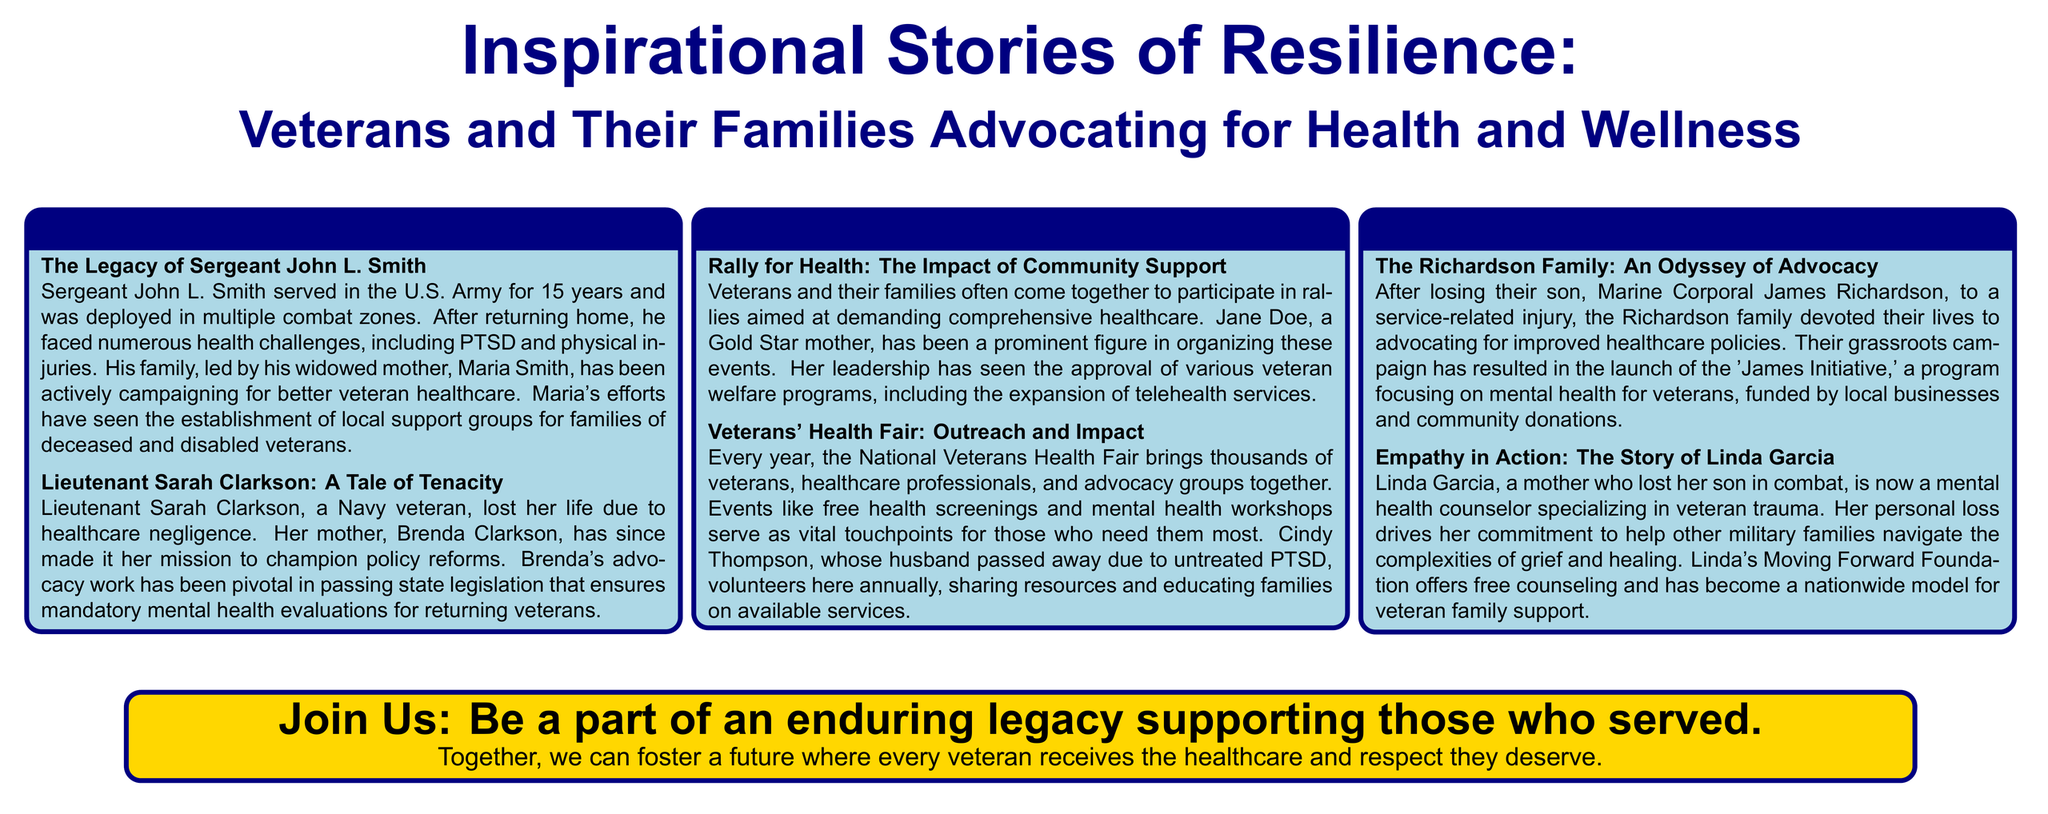What is the title of the poster? The title of the poster is highlighted prominently and summarizes the main theme.
Answer: Inspirational Stories of Resilience: Veterans and Their Families Advocating for Health and Wellness Who is the subject of the story titled "The Legacy of Sergeant John L. Smith"? The subject of the story is a U.S. Army sergeant who faced health challenges after service.
Answer: Sergeant John L. Smith What initiative did the Richardson family launch? The initiative focuses on mental health for veterans and is named after their son.
Answer: James Initiative Who organized the health fair mentioned in the poster? The health fair is organized by a national veterans group, which brings together various stakeholders.
Answer: National Veterans Health Fair What color is used for the background of the title box? The color is consistent with the theme and helps to distinguish different sections of the poster.
Answer: Navy What is Brenda Clarkson advocating for after her daughter's death? Brenda Clarkson's advocacy focuses on ensuring specific healthcare reforms for veterans.
Answer: Policy reforms How many stories are presented in the poster? The stories are organized within three themed boxes, indicating the structure of the content.
Answer: Three What program does Linda Garcia's foundation offer? The program focuses on mental health counseling for military families affected by trauma.
Answer: Free counseling What is the purpose of attending rallies, as mentioned in the poster? The purpose is to demand comprehensive healthcare for veterans and support their well-being.
Answer: Comprehensive healthcare 